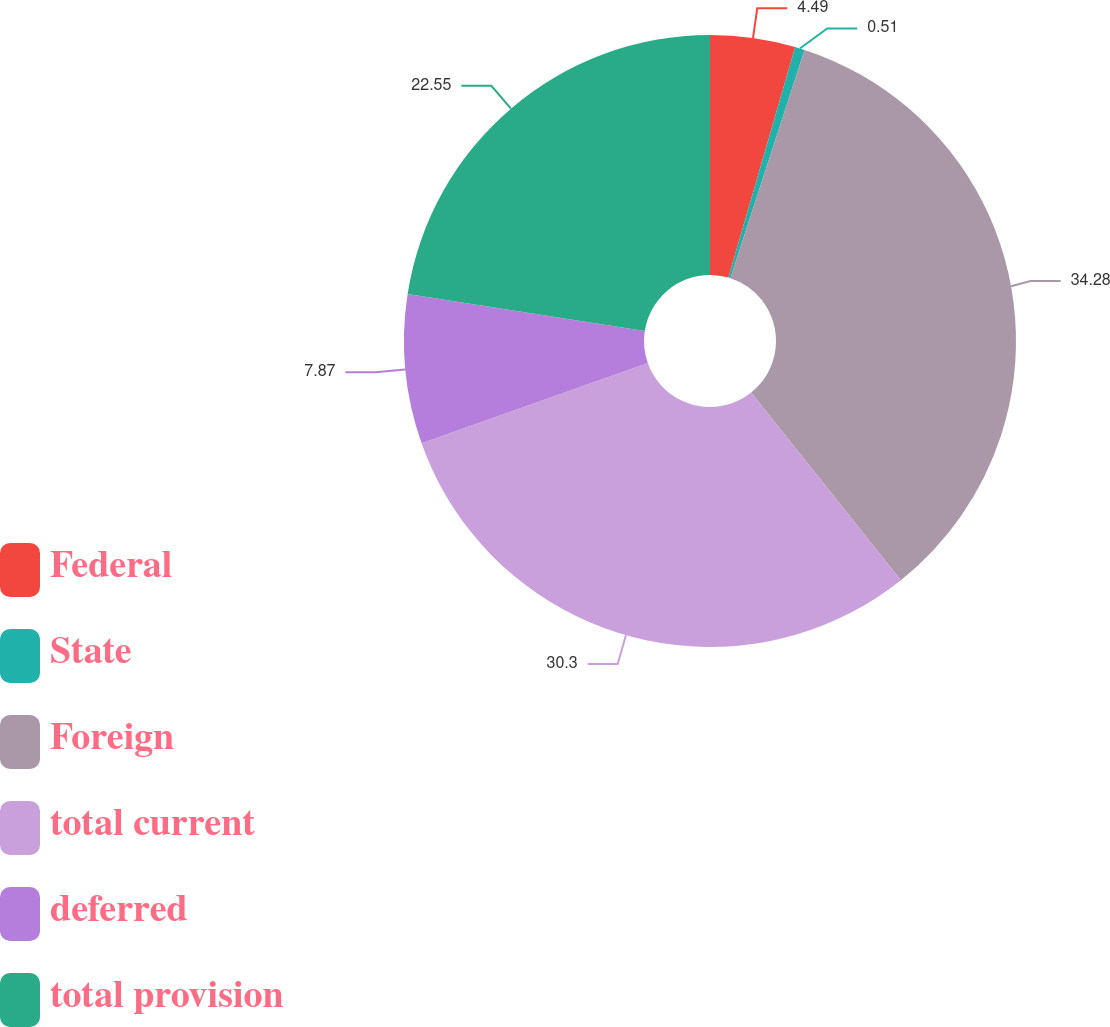Convert chart. <chart><loc_0><loc_0><loc_500><loc_500><pie_chart><fcel>Federal<fcel>State<fcel>Foreign<fcel>total current<fcel>deferred<fcel>total provision<nl><fcel>4.49%<fcel>0.51%<fcel>34.28%<fcel>30.3%<fcel>7.87%<fcel>22.55%<nl></chart> 